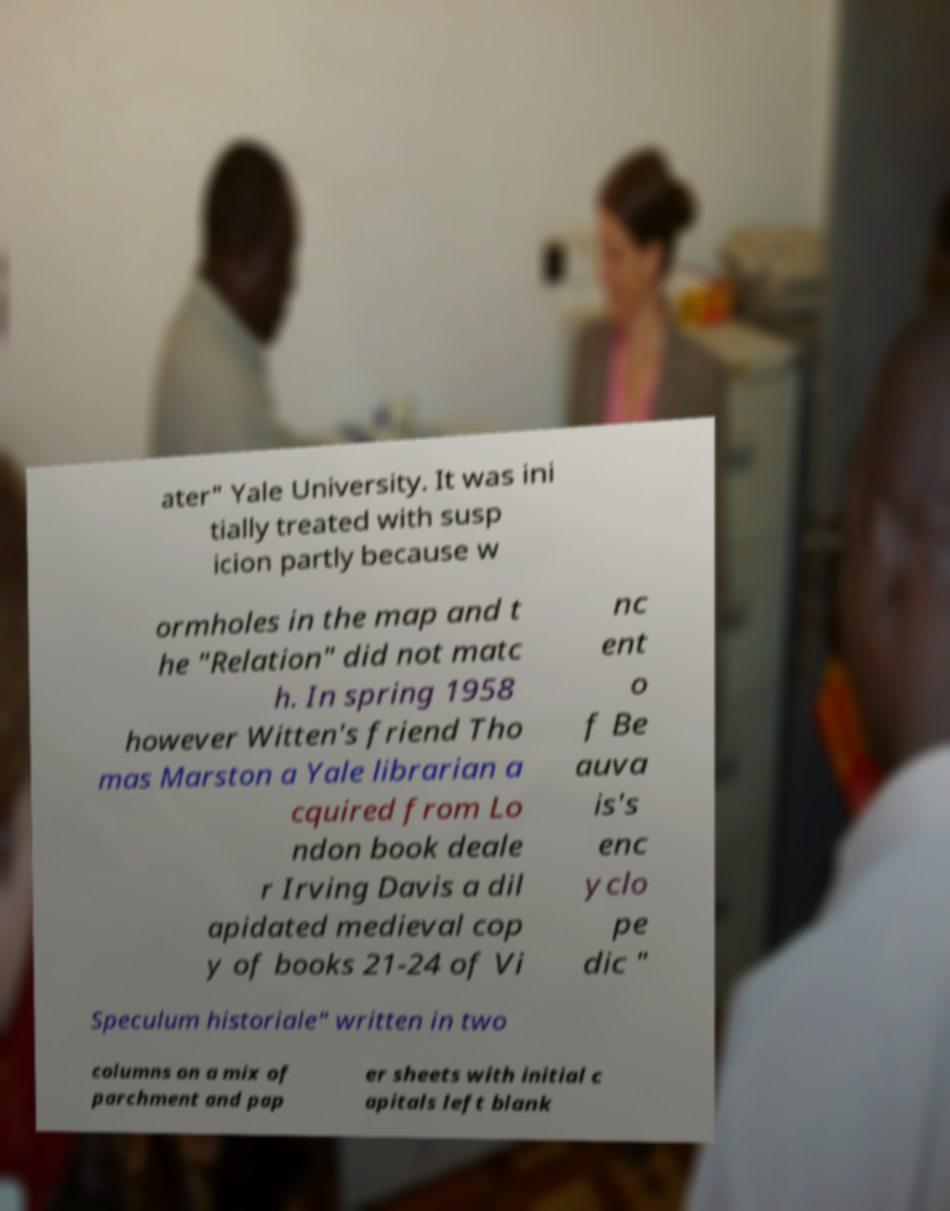Could you assist in decoding the text presented in this image and type it out clearly? ater" Yale University. It was ini tially treated with susp icion partly because w ormholes in the map and t he "Relation" did not matc h. In spring 1958 however Witten's friend Tho mas Marston a Yale librarian a cquired from Lo ndon book deale r Irving Davis a dil apidated medieval cop y of books 21-24 of Vi nc ent o f Be auva is's enc yclo pe dic " Speculum historiale" written in two columns on a mix of parchment and pap er sheets with initial c apitals left blank 